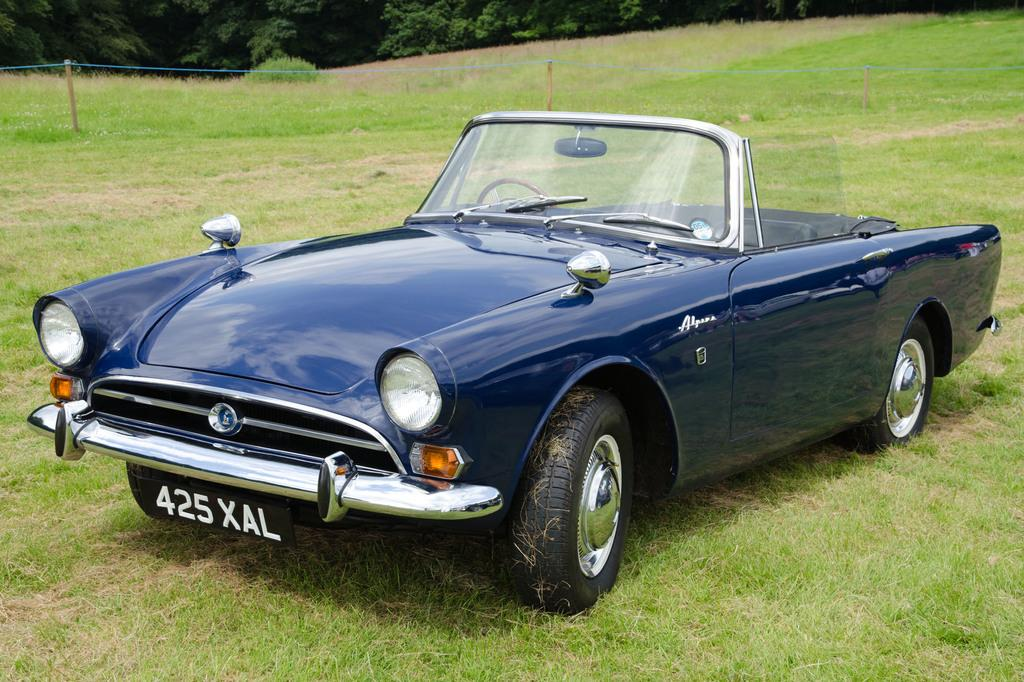What type of vehicle is in the image? There is a black car in the image. Where is the car located? The car is on a grass field. What can be seen in the background of the image? There are trees in the background of the image. What type of bottle is visible on the front of the car? There is no bottle visible on the front of the car in the image. 